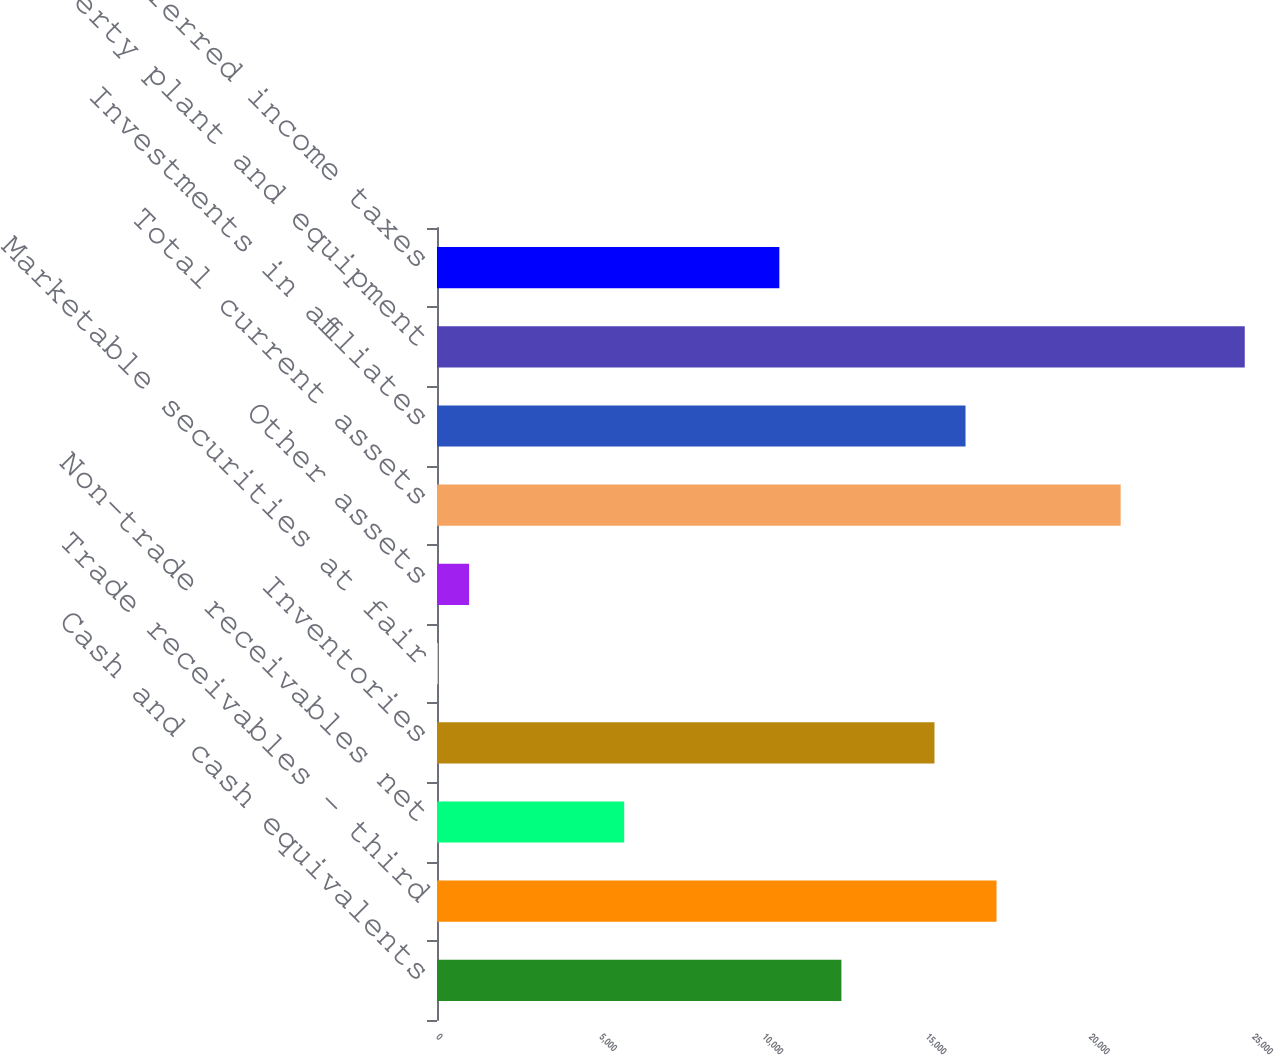Convert chart to OTSL. <chart><loc_0><loc_0><loc_500><loc_500><bar_chart><fcel>Cash and cash equivalents<fcel>Trade receivables - third<fcel>Non-trade receivables net<fcel>Inventories<fcel>Marketable securities at fair<fcel>Other assets<fcel>Total current assets<fcel>Investments in affiliates<fcel>Property plant and equipment<fcel>Deferred income taxes<nl><fcel>12389.8<fcel>17142.8<fcel>5735.6<fcel>15241.6<fcel>32<fcel>982.6<fcel>20945.2<fcel>16192.2<fcel>24747.6<fcel>10488.6<nl></chart> 